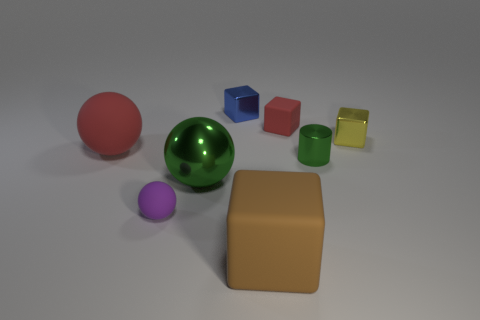Can you tell me the colors of the spheres present in the image and their relative sizes? Certainly! The image features two spheres: one is a large green sphere, and the other is a smaller pink sphere. The green sphere is the larger of the two, quite prominently displayed toward the center, while the pink sphere is distinctly smaller and positioned near the front. 